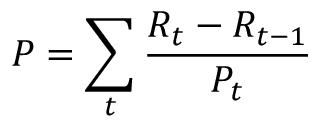<formula> <loc_0><loc_0><loc_500><loc_500>P = \sum _ { t } \frac { R _ { t } - R _ { t - 1 } } { P _ { t } }</formula> 